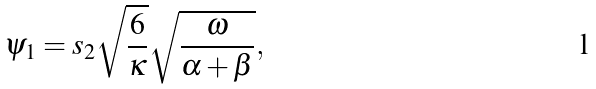<formula> <loc_0><loc_0><loc_500><loc_500>\psi _ { 1 } = s _ { 2 } \sqrt { \frac { 6 } { \kappa } } \sqrt { \frac { \omega } { \alpha + \beta } } ,</formula> 